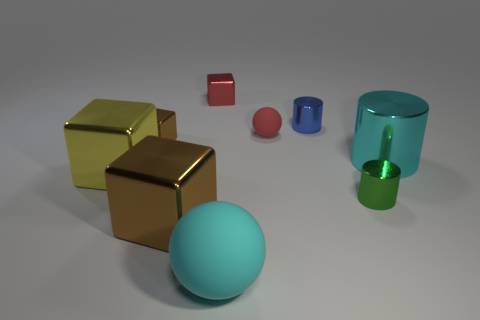Subtract all yellow cubes. How many cubes are left? 3 Subtract all blue cylinders. How many cylinders are left? 2 Subtract all cubes. How many objects are left? 5 Subtract 3 cylinders. How many cylinders are left? 0 Subtract all green blocks. How many cyan cylinders are left? 1 Subtract all small red cylinders. Subtract all small green metallic cylinders. How many objects are left? 8 Add 4 shiny cubes. How many shiny cubes are left? 8 Add 9 large matte cubes. How many large matte cubes exist? 9 Subtract 0 purple cubes. How many objects are left? 9 Subtract all brown cylinders. Subtract all blue cubes. How many cylinders are left? 3 